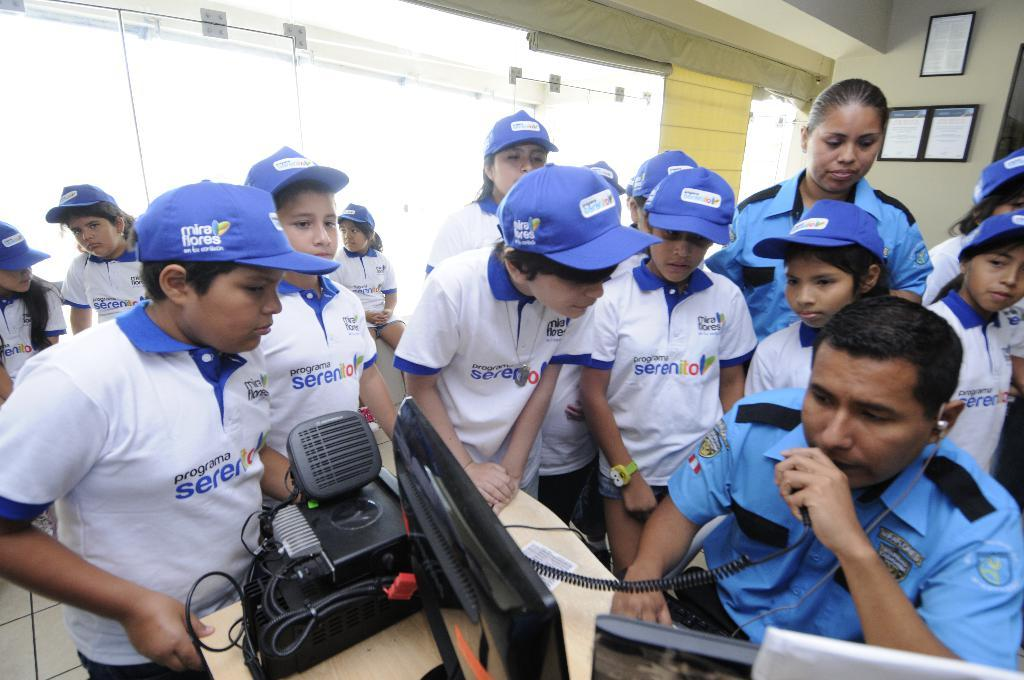<image>
Describe the image concisely. young men wear blue hats that says Mira Bores on them 